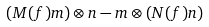<formula> <loc_0><loc_0><loc_500><loc_500>( M ( f ) m ) \otimes n - m \otimes ( N ( f ) n )</formula> 